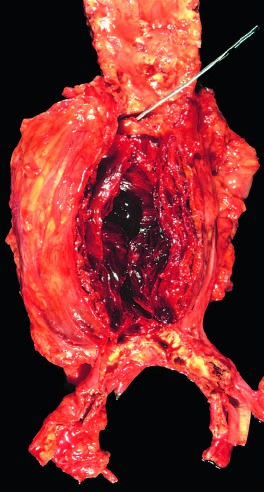what is filled by a large, layered thrombus?
Answer the question using a single word or phrase. The lumen 